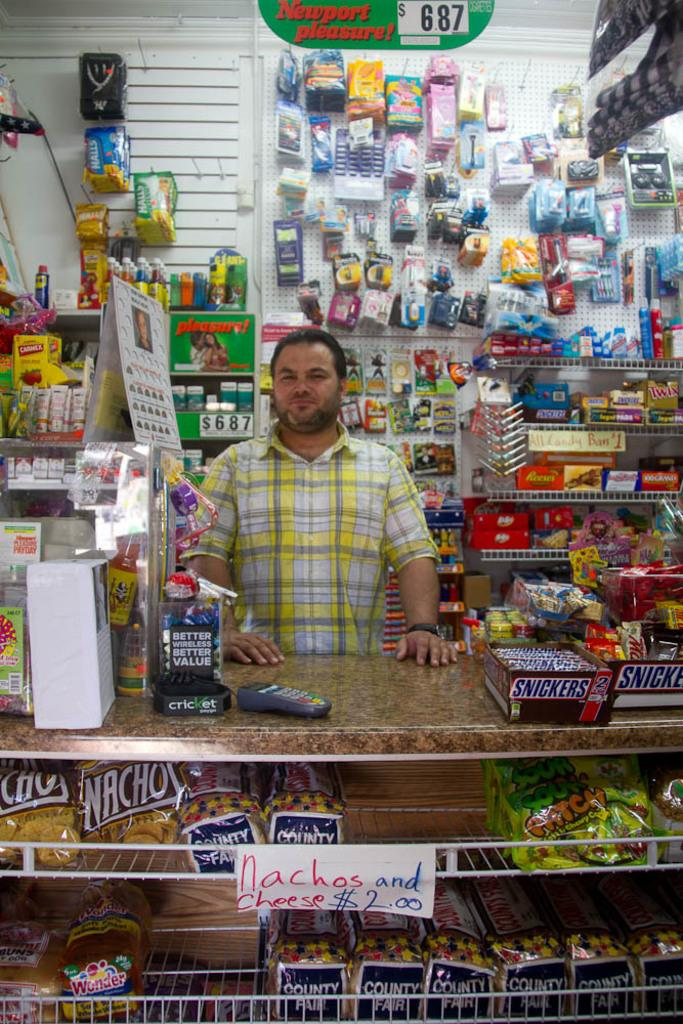<image>
Present a compact description of the photo's key features. A man standing behind a counter with a box of snickers on it. 